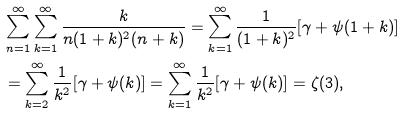Convert formula to latex. <formula><loc_0><loc_0><loc_500><loc_500>& \sum _ { n = 1 } ^ { \infty } \sum _ { k = 1 } ^ { \infty } \frac { k } { n ( 1 + k ) ^ { 2 } ( n + k ) } = \sum _ { k = 1 } ^ { \infty } \frac { 1 } { ( 1 + k ) ^ { 2 } } [ \gamma + \psi ( 1 + k ) ] \\ & = \sum _ { k = 2 } ^ { \infty } \frac { 1 } { k ^ { 2 } } [ \gamma + \psi ( k ) ] = \sum _ { k = 1 } ^ { \infty } \frac { 1 } { k ^ { 2 } } [ \gamma + \psi ( k ) ] = \zeta ( 3 ) ,</formula> 